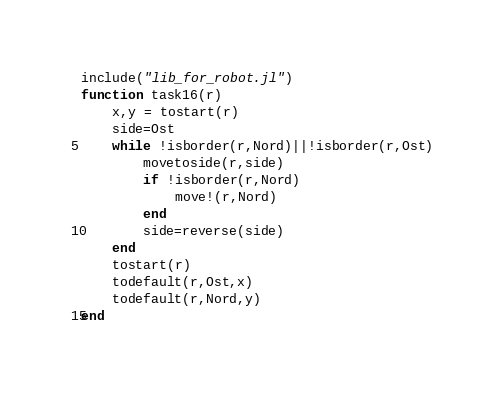<code> <loc_0><loc_0><loc_500><loc_500><_Julia_>include("lib_for_robot.jl")
function task16(r)
    x,y = tostart(r)
    side=Ost
    while !isborder(r,Nord)||!isborder(r,Ost)
        movetoside(r,side)
        if !isborder(r,Nord)
            move!(r,Nord)
        end
        side=reverse(side)
    end
    tostart(r)
    todefault(r,Ost,x)
    todefault(r,Nord,y)
end</code> 